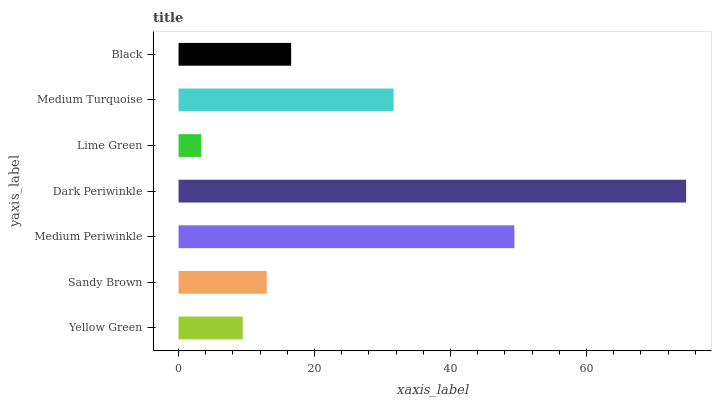Is Lime Green the minimum?
Answer yes or no. Yes. Is Dark Periwinkle the maximum?
Answer yes or no. Yes. Is Sandy Brown the minimum?
Answer yes or no. No. Is Sandy Brown the maximum?
Answer yes or no. No. Is Sandy Brown greater than Yellow Green?
Answer yes or no. Yes. Is Yellow Green less than Sandy Brown?
Answer yes or no. Yes. Is Yellow Green greater than Sandy Brown?
Answer yes or no. No. Is Sandy Brown less than Yellow Green?
Answer yes or no. No. Is Black the high median?
Answer yes or no. Yes. Is Black the low median?
Answer yes or no. Yes. Is Dark Periwinkle the high median?
Answer yes or no. No. Is Dark Periwinkle the low median?
Answer yes or no. No. 